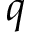Convert formula to latex. <formula><loc_0><loc_0><loc_500><loc_500>q</formula> 